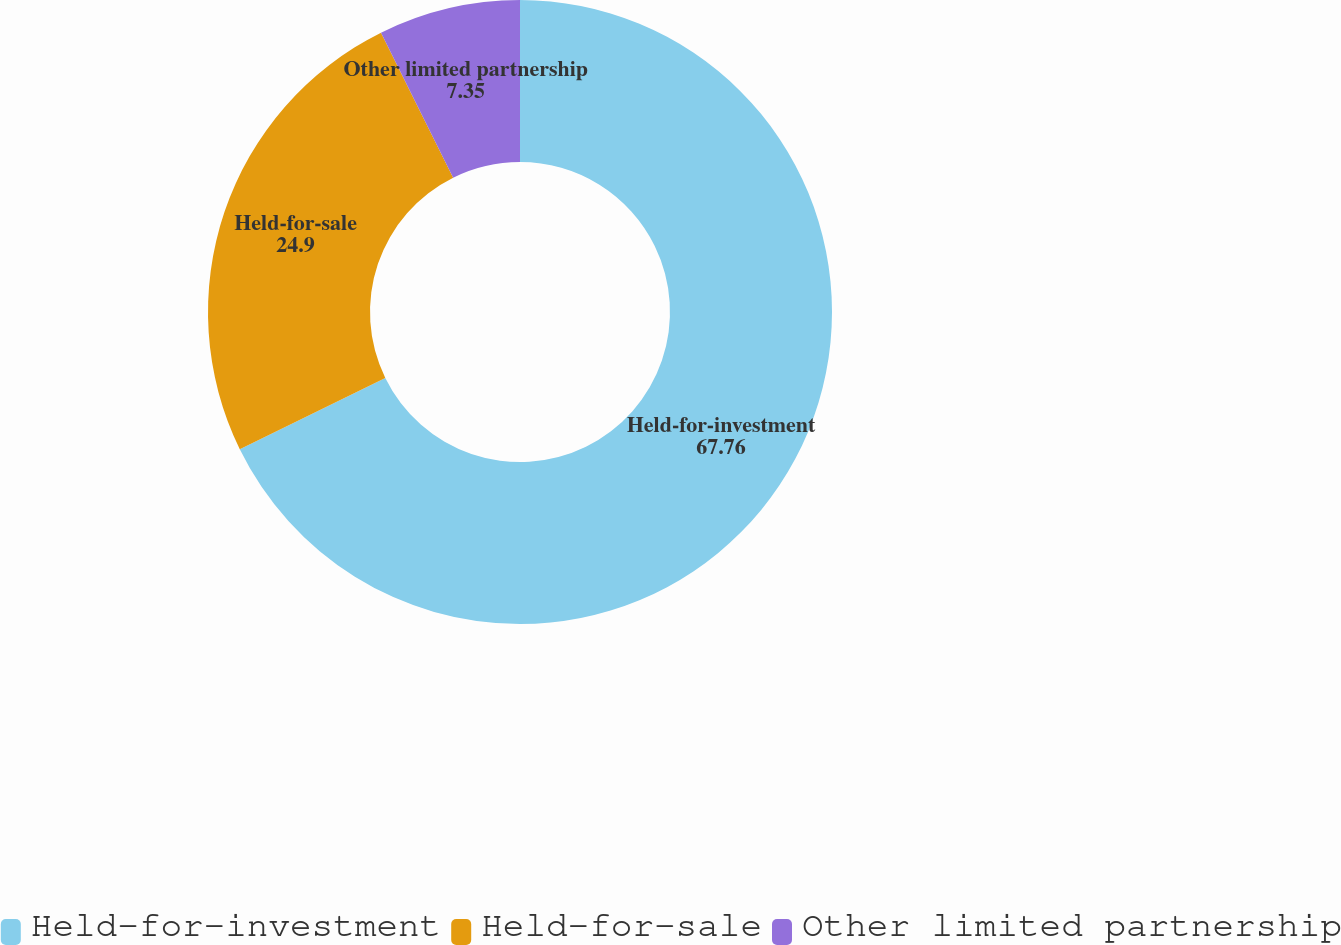<chart> <loc_0><loc_0><loc_500><loc_500><pie_chart><fcel>Held-for-investment<fcel>Held-for-sale<fcel>Other limited partnership<nl><fcel>67.76%<fcel>24.9%<fcel>7.35%<nl></chart> 